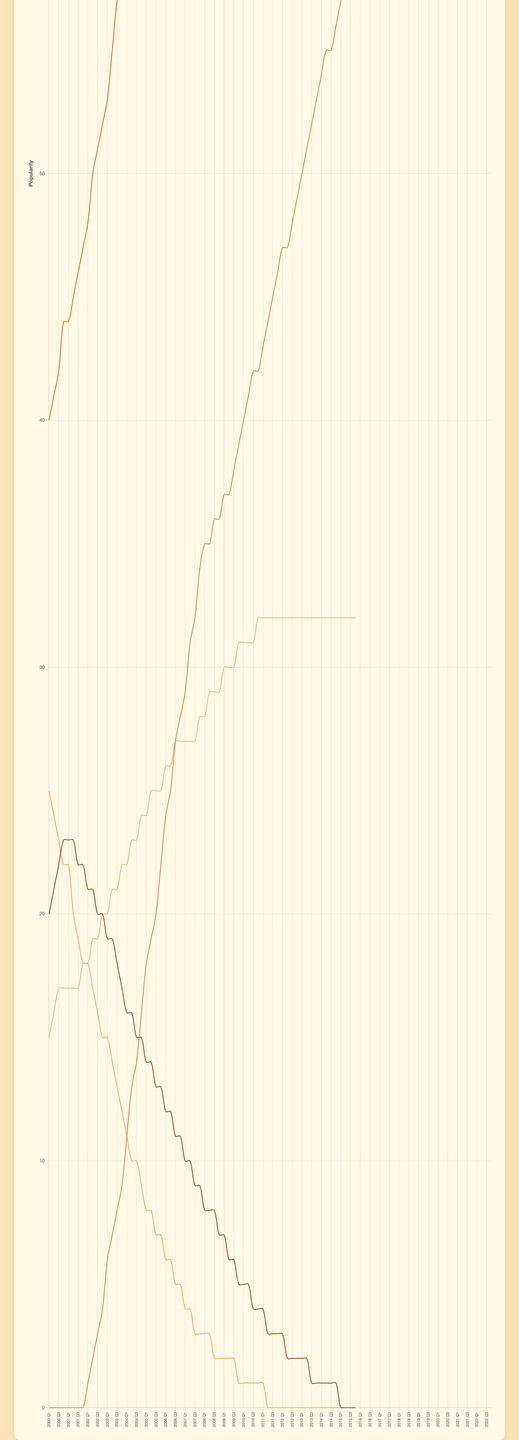What is the overall trend of "Traditional Country" popularity from 2000 to 2022? The "Traditional Country" subgenre starts at a popularity of 20 in 2000 and gradually decreases over time, eventually reaching 0 by 2022. The trend is a continuous decline.
Answer: Decreasing Which subgenre becomes the most popular by 2022? By looking at the final data points for each subgenre in 2022, "Country Pop" has reached a consistent value of 100, making it the most popular subgenre by 2022.
Answer: Country Pop How does the trend of "Bro-Country" compare to "Traditional Country" from 2000 to 2022? "Bro-Country" starts from 0 and shows a steady increase over time, ending at 60 in 2022. In contrast, "Traditional Country" starts from 20 and gradually decreases to 0 by 2022. Therefore, "Bro-Country" increases while "Traditional Country" decreases.
Answer: Bro-Country increases, Traditional Country decreases What is the maximum difference in popularity between "Country Pop" and "Alt-Country"? The maximum popularity of "Country Pop" is 100 (from 2016 Q4 onwards). "Alt-Country" reaches its minimum value of 0 multiple times after 2011. Thus, the maximum difference in popularity is 100 - 0 = 100.
Answer: 100 Which subgenre shows the least variation in popularity over the given time period? By observing the lines’ stability, "Americana" remains fairly constant, starting at 15 and leveling off around 32, indicating the least variation in popularity.
Answer: Americana During which period did "Bro-Country" start to rise significantly? Observing the upward trend, "Bro-Country" starts to rise significantly around 2002 Q1 when it begins its upward trajectory from 0 to 1 and continues increasing.
Answer: 2002 Q1 What subgenre had a popularity of around 25 in the year 2000 and then experienced a decline? "Alt-Country" starts with a popularity of 25 in 2000 Q1 and then shows a declining trend, reaching 0 by 2011 Q4.
Answer: Alt-Country Compare the popularity trends of "Americana" and "Alt-Country" between 2005 and 2010? Between 2005 and 2010, "Americana" shows a steady and slight increase from around 24 to 32, whereas "Alt-Country" continues its decline from about 8 to 3 during the same period.
Answer: Americana increases, Alt-Country decreases Which subgenre stabilizes at a constant value after some fluctuations, and what is that value? "Americana" stabilizes at a value of 32 after some fluctuations in the earlier years of the period.
Answer: 32 